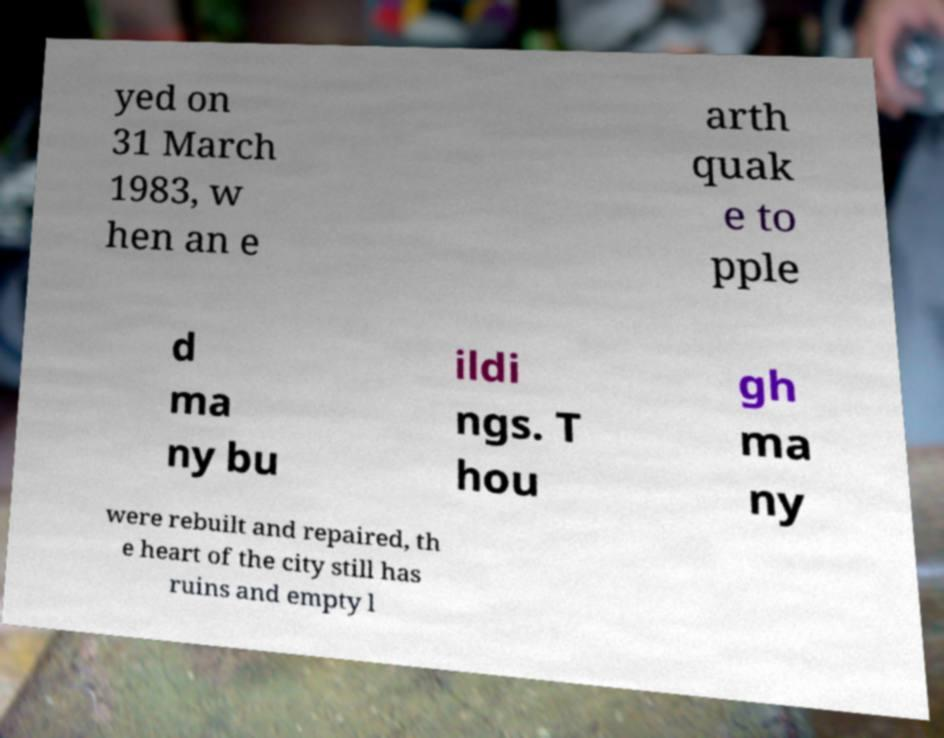There's text embedded in this image that I need extracted. Can you transcribe it verbatim? yed on 31 March 1983, w hen an e arth quak e to pple d ma ny bu ildi ngs. T hou gh ma ny were rebuilt and repaired, th e heart of the city still has ruins and empty l 